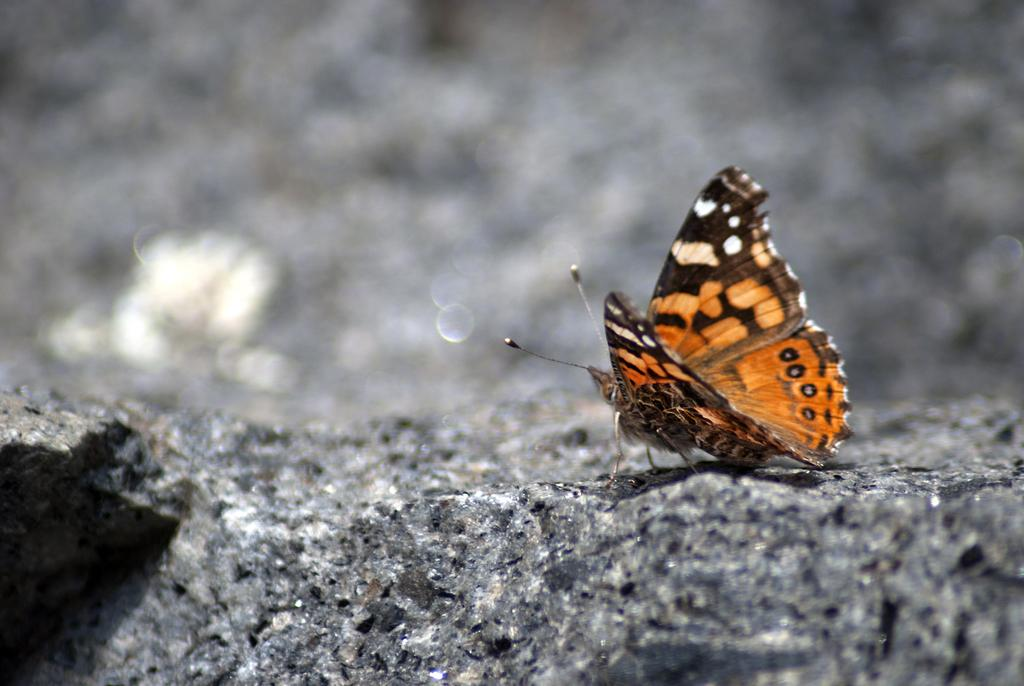What is the main subject of the image? There is a butterfly in the image. Where is the butterfly located? The butterfly is on a stone surface. How would you describe the background of the image? The background of the image has a blurred view. What type of stew is the butterfly cooking in the image? There is no stew or cooking activity present in the image; it features a butterfly on a stone surface. Why is the butterfly crying in the image? There is no indication that the butterfly is crying in the image; it is simply resting on a stone surface. 